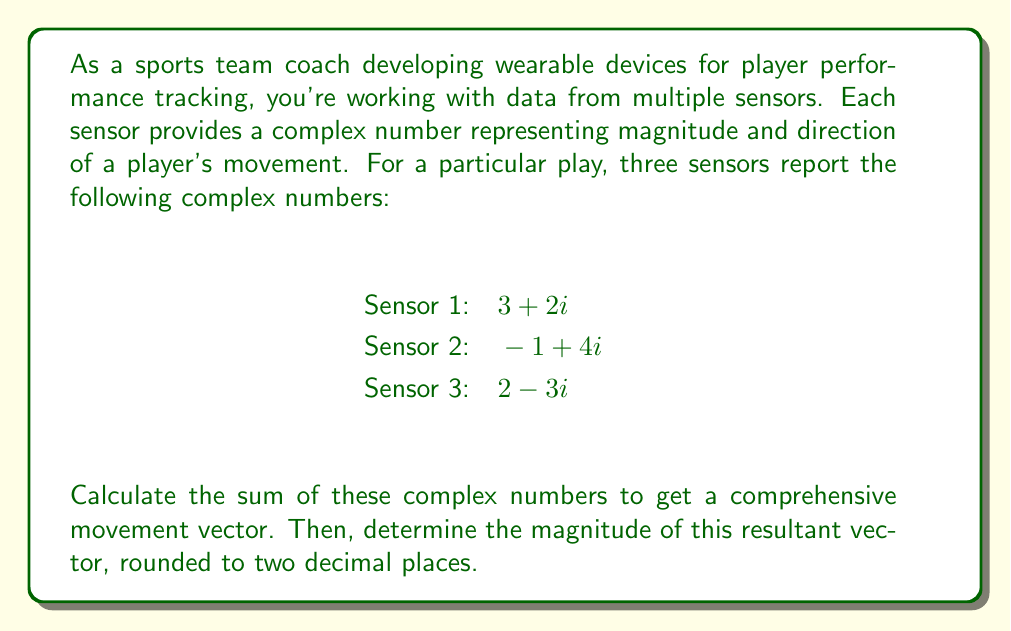Solve this math problem. To solve this problem, we'll follow these steps:

1) First, we need to add the complex numbers from all three sensors:

   $$(3 + 2i) + (-1 + 4i) + (2 - 3i)$$

2) We can add the real and imaginary parts separately:

   Real part: $3 + (-1) + 2 = 4$
   Imaginary part: $2i + 4i + (-3i) = 3i$

3) The sum of the complex numbers is:

   $$4 + 3i$$

4) This sum represents our comprehensive movement vector.

5) To find the magnitude of this vector, we use the formula:

   $$|a + bi| = \sqrt{a^2 + b^2}$$

   Where $a$ is the real part and $b$ is the coefficient of the imaginary part.

6) Substituting our values:

   $$|4 + 3i| = \sqrt{4^2 + 3^2}$$

7) Simplify:

   $$\sqrt{16 + 9} = \sqrt{25} = 5$$

8) The magnitude is exactly 5, so rounded to two decimal places it remains 5.00.
Answer: 5.00 